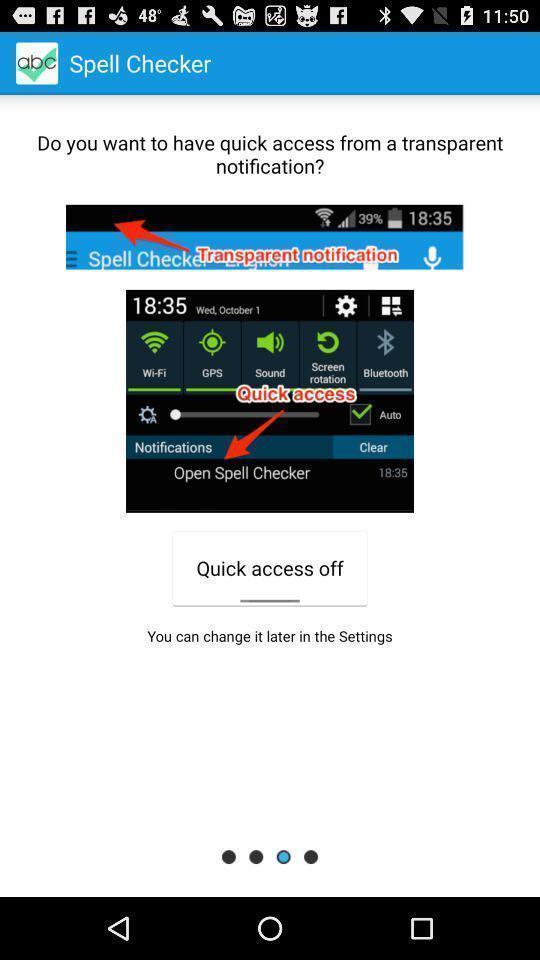Provide a textual representation of this image. Window displaying status bar page. 